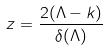<formula> <loc_0><loc_0><loc_500><loc_500>z = \frac { 2 ( \Lambda - k ) } { \delta ( \Lambda ) }</formula> 